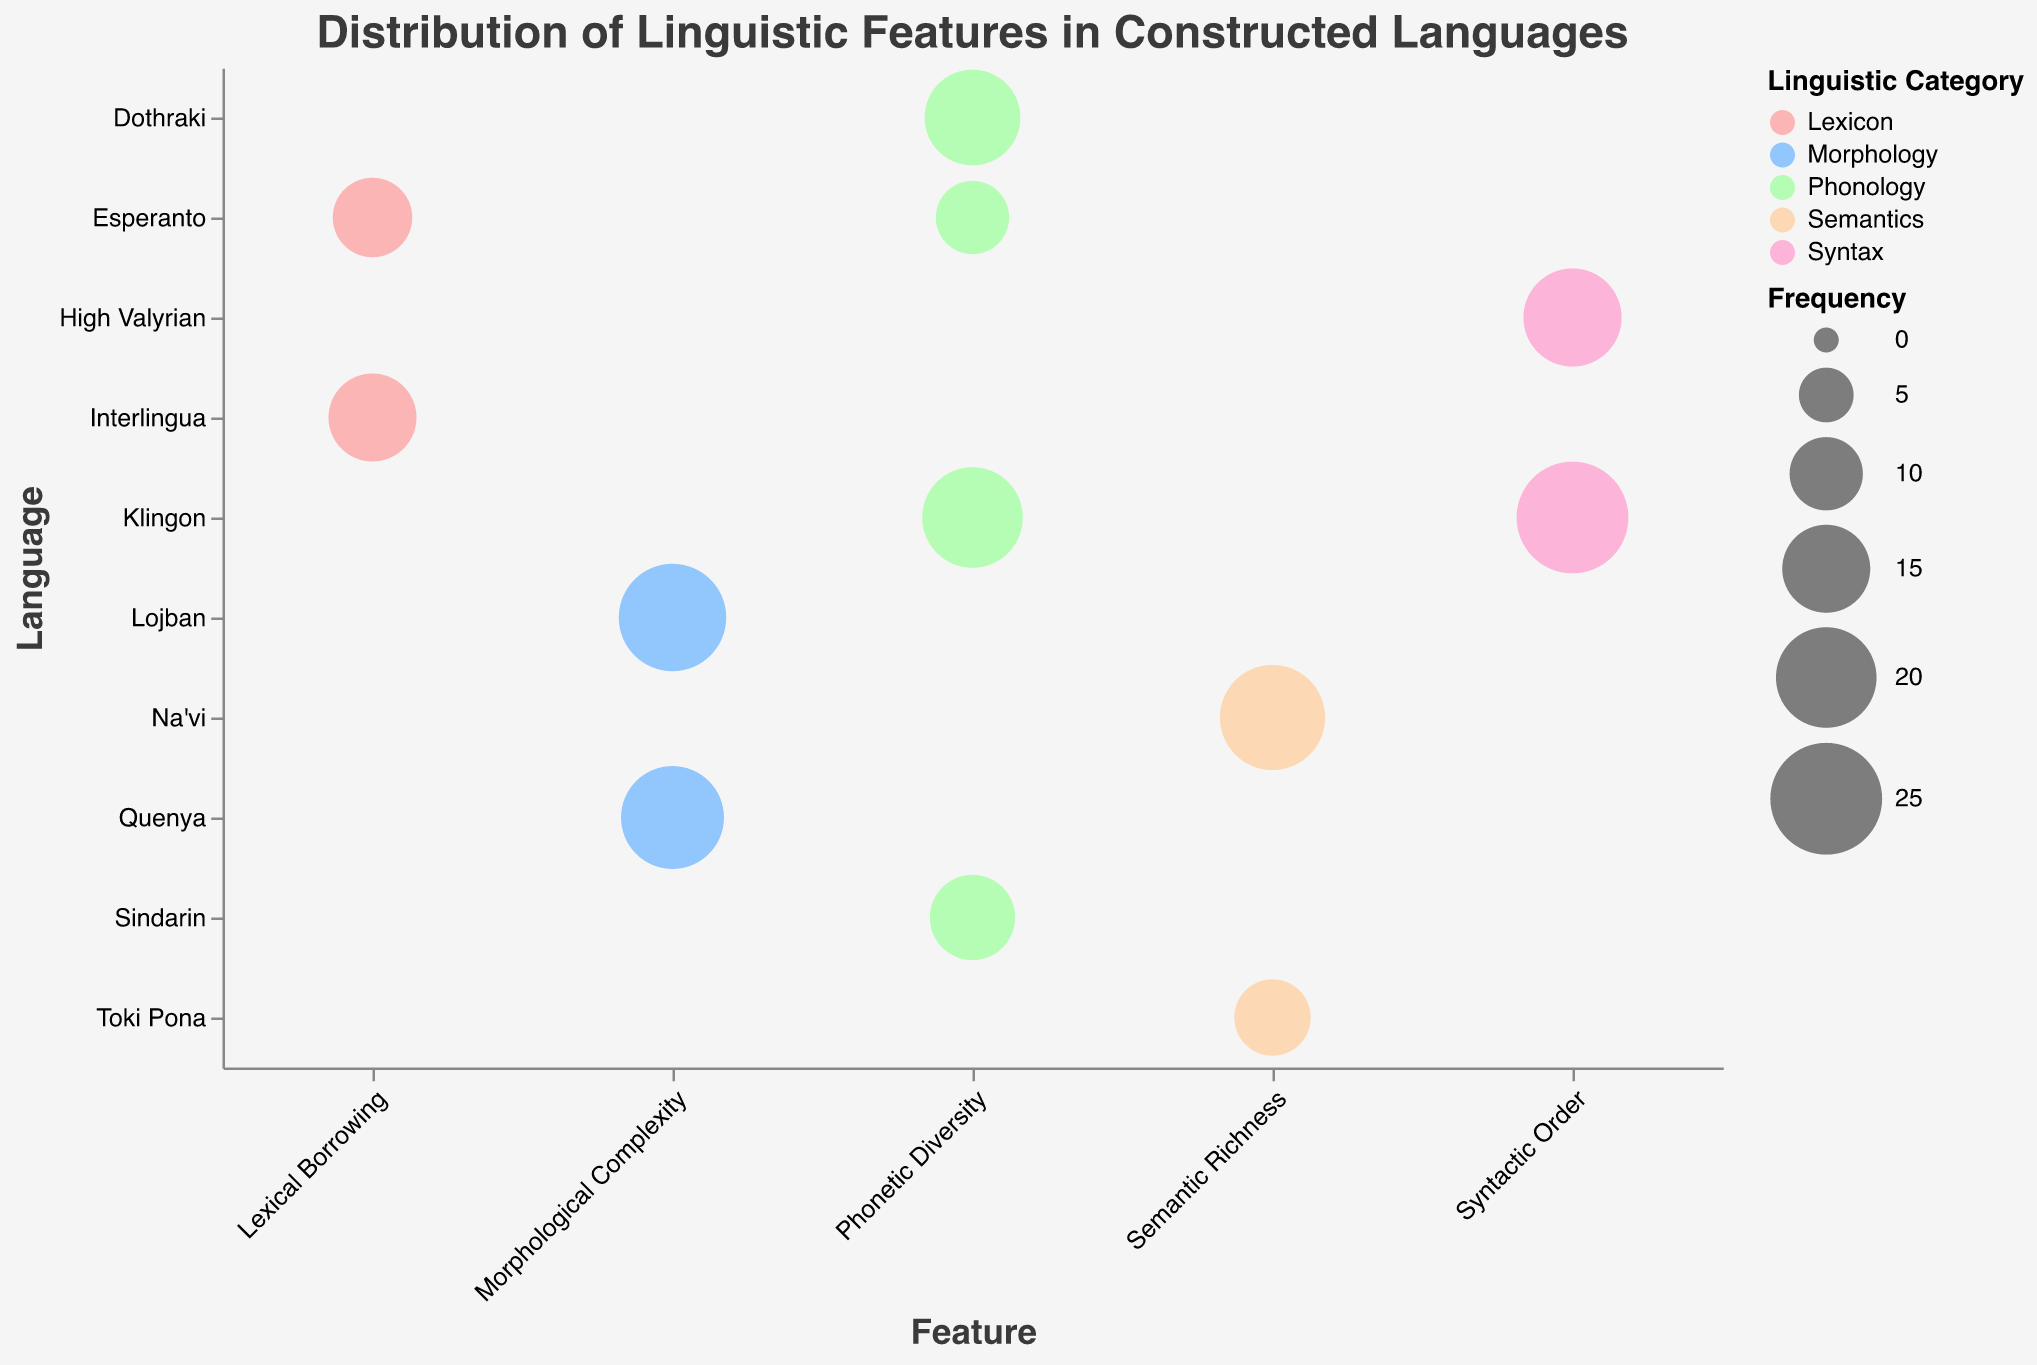what is the title of the figure? The title is usually placed at the top of the figure. In this case, it is "Distribution of Linguistic Features in Constructed Languages."
Answer: Distribution of Linguistic Features in Constructed Languages What are the linguistic categories presented in the chart? The color legend shows the linguistic categories, which are: Phonology, Lexicon, Morphology, Syntax, and Semantics.
Answer: Phonology, Lexicon, Morphology, Syntax, Semantics Which constructed language has the highest frequency value for a feature? By examining the size of the bubbles, Klingon has the largest bubble with a Frequency of 25 for the feature Syntactic Order.
Answer: Klingon Compare the Phonetic Diversity of Klingon and Sindarin. Which one has a higher frequency? Look at the Phonetic Diversity row and compare the bubble sizes corresponding to Klingon and Sindarin. Klingon has a frequency of 20, while Sindarin has 14.
Answer: Klingon Which conlangs are represented under the category Semantics? By looking at the bubbles colored for the Semantics category, the languages Na'vi and Toki Pona are represented.
Answer: Na'vi, Toki Pona What's the total frequency for the Phonetic Diversity feature across all languages? The frequencies for Phonetic Diversity are: Klingon (20), Sindarin (14), Dothraki (18), and Esperanto (10). Add them up: 20 + 14 + 18 + 10 = 62
Answer: 62 Identify the language with the lowest frequency value in the category Lexicon. Among the bubbles in the Lexicon category, Esperanto has a Frequency of 12 which is lower compared to Interlingua's 15.
Answer: Esperanto Which feature has the highest average scale value across all languages mentioned in the chart? Calculate the average scale for each feature: Phonetic Diversity (19), Lexical Borrowing (8.5), Morphological Complexity (6.5), Syntactic Order (7.5), Semantic Richness (6.5). Lexical Borrowing has the highest average scale (8.5).
Answer: Lexical Borrowing How does the frequency of Syntactic Order in High Valyrian compare to that in Klingon? Find the frequency values for Syntactic Order for both languages. For High Valyrian, it’s 19, and for Klingon, it’s 25. Compare these values: 19 < 25.
Answer: Klingon Which language with the feature `Morphological Complexity` shows a higher frequency, Lojban or Quenya? In the Morphological Complexity row, compare the bubble sizes of Lojban and Quenya. Lojban has a Frequency of 23, whereas Quenya has 21.
Answer: Lojban 